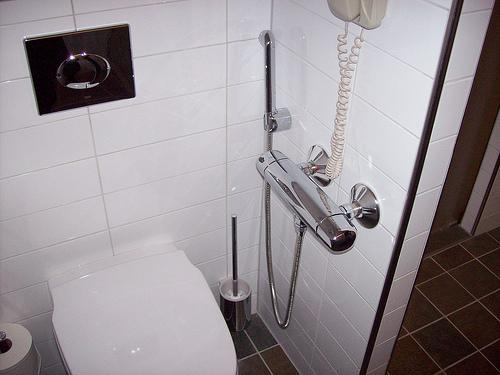What objects are positioned next to the toilet in the image? A scrub brush to the right of the toilet and white toilet paper to the left. Can you describe the location and shape of the button found in the bathroom? The round button is located in the center of a chrome plate on the wall above the toilet. Describe the major color and pattern used for the walls and floor in the image. The walls are covered in white tiles while the floor is made of brown tiles. Explain the appearance and placement of the phone in the bathroom. The phone is cream-colored, mounted on the wall, and connected by a spiral cord. What is the color and location of the toilet paper in the image? The toilet paper is white and located to the left of the toilet. Identify the key elements in the bathroom related to hygiene and cleanliness. There is a white toilet with a closed lid, a roll of toilet paper, a toilet scrub brush in a canister, and a silvertone wall-mounted dryer. How many different tile features are present in the bathroom and what are their colors?  There are two tile features: white tiles on the wall and dark tiles on the floor. What kind of brush is there in the bathroom, and where is it? Toilet scrub brush, to the right of the toilet How many types of tiles are there in the bathroom, and what colors are they? Two types - white wall tiles and brown floor tiles What is the color of the floor in the bathroom? Brown Where is the handlebar located in the bathroom? Attached to the wall I want you to look for a framed picture hanging on the tiled wall, showcasing a serene landscape. Examine its details closely and let me know what you think. None of the objects described in the image mention a framed picture, thus it is not present in the image. Pay close attention to the luxurious, fluffy bath mat placed on the brown tile floor. How does its texture and color contrast with the surrounding tiles? No, it's not mentioned in the image. Identify the object located in the center of the chrome plate on the wall. Round button Describe the overall appearance of the bathroom. Bathroom with white wall tiles and brown floor tiles, containing a toilet, toilet paper, scrub brush, and phone Is there a phone in the bathroom? If so, where is it located? Yes, the phone is attached to the wall. Is there a pipe running down the wall in the bathroom? If so, which part of the wall is it on? Yes, it's on the left side of the wall. Which object is placed to the right of the toilet? Scrub brush What type of brush is in the bathroom? Toilet scrub brush Is there a phone cord visible in the bathroom? If so, what's the cord's shape? Yes, it's a spiral phone cord. What is the main color of the bathroom walls? White Choose the correct description of the object above the toilet: (a) round button in center of plate, (b) toilet flusher, (c) toiletflushing sensor on wall (b) toilet flusher What is the color of the telephone in the bathroom? Cream-colored Identify the type of floor in the bathroom. Brown tile Could you list three objects that can be found in the bathroom? Toilet, toilet paper roll, scrub brush Choose the correct designation for the phone in the bathroom: (a) wall-mounted, (b) tabletop, (c) floor-standing (a) wall-mounted What is the purpose of the silver attachment on the bathroom wall? Toilet flusher Identify the objects present in the bathroom. Toilet, toilet paper, scrub brush, phone, phone cord, handlebar Describe the toilet paper's position in relation to the toilet. To the left of the toilet Search for the elegant chandelier hanging from the ceiling, providing ample lighting for the bathroom. Describe the style and any intricate details it might have. A chandelier is not described in the list of objects, which means it does not exist in the image. 